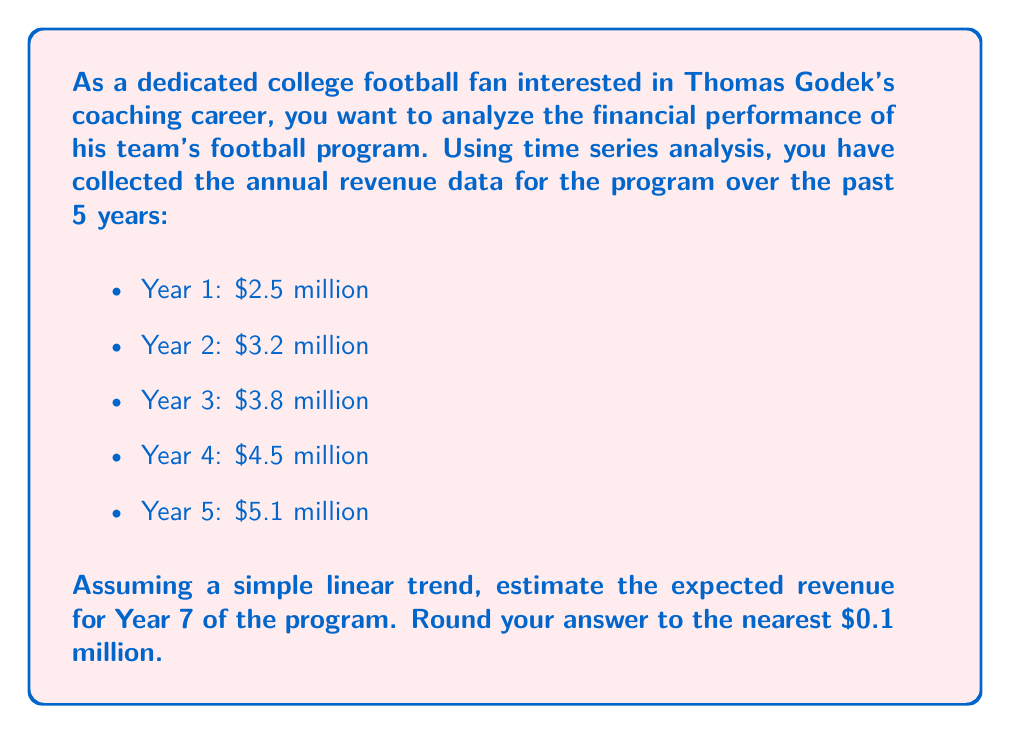Could you help me with this problem? To estimate the expected revenue for Year 7 using a simple linear trend, we'll follow these steps:

1. Calculate the average year-over-year increase in revenue:
   $\frac{(3.2 - 2.5) + (3.8 - 3.2) + (4.5 - 3.8) + (5.1 - 4.5)}{4} = \frac{0.7 + 0.6 + 0.7 + 0.6}{4} = \frac{2.6}{4} = 0.65$ million

2. Use the linear trend formula:
   $Y_t = Y_0 + b \cdot t$
   Where:
   $Y_t$ is the estimated revenue for year t
   $Y_0$ is the initial revenue (Year 1)
   $b$ is the average year-over-year increase
   $t$ is the number of years from the initial year

3. Calculate the estimated revenue for Year 7:
   $Y_7 = 2.5 + 0.65 \cdot 6 = 2.5 + 3.9 = 6.4$ million

Therefore, the estimated revenue for Year 7 is $6.4 million.
Answer: $6.4 million 